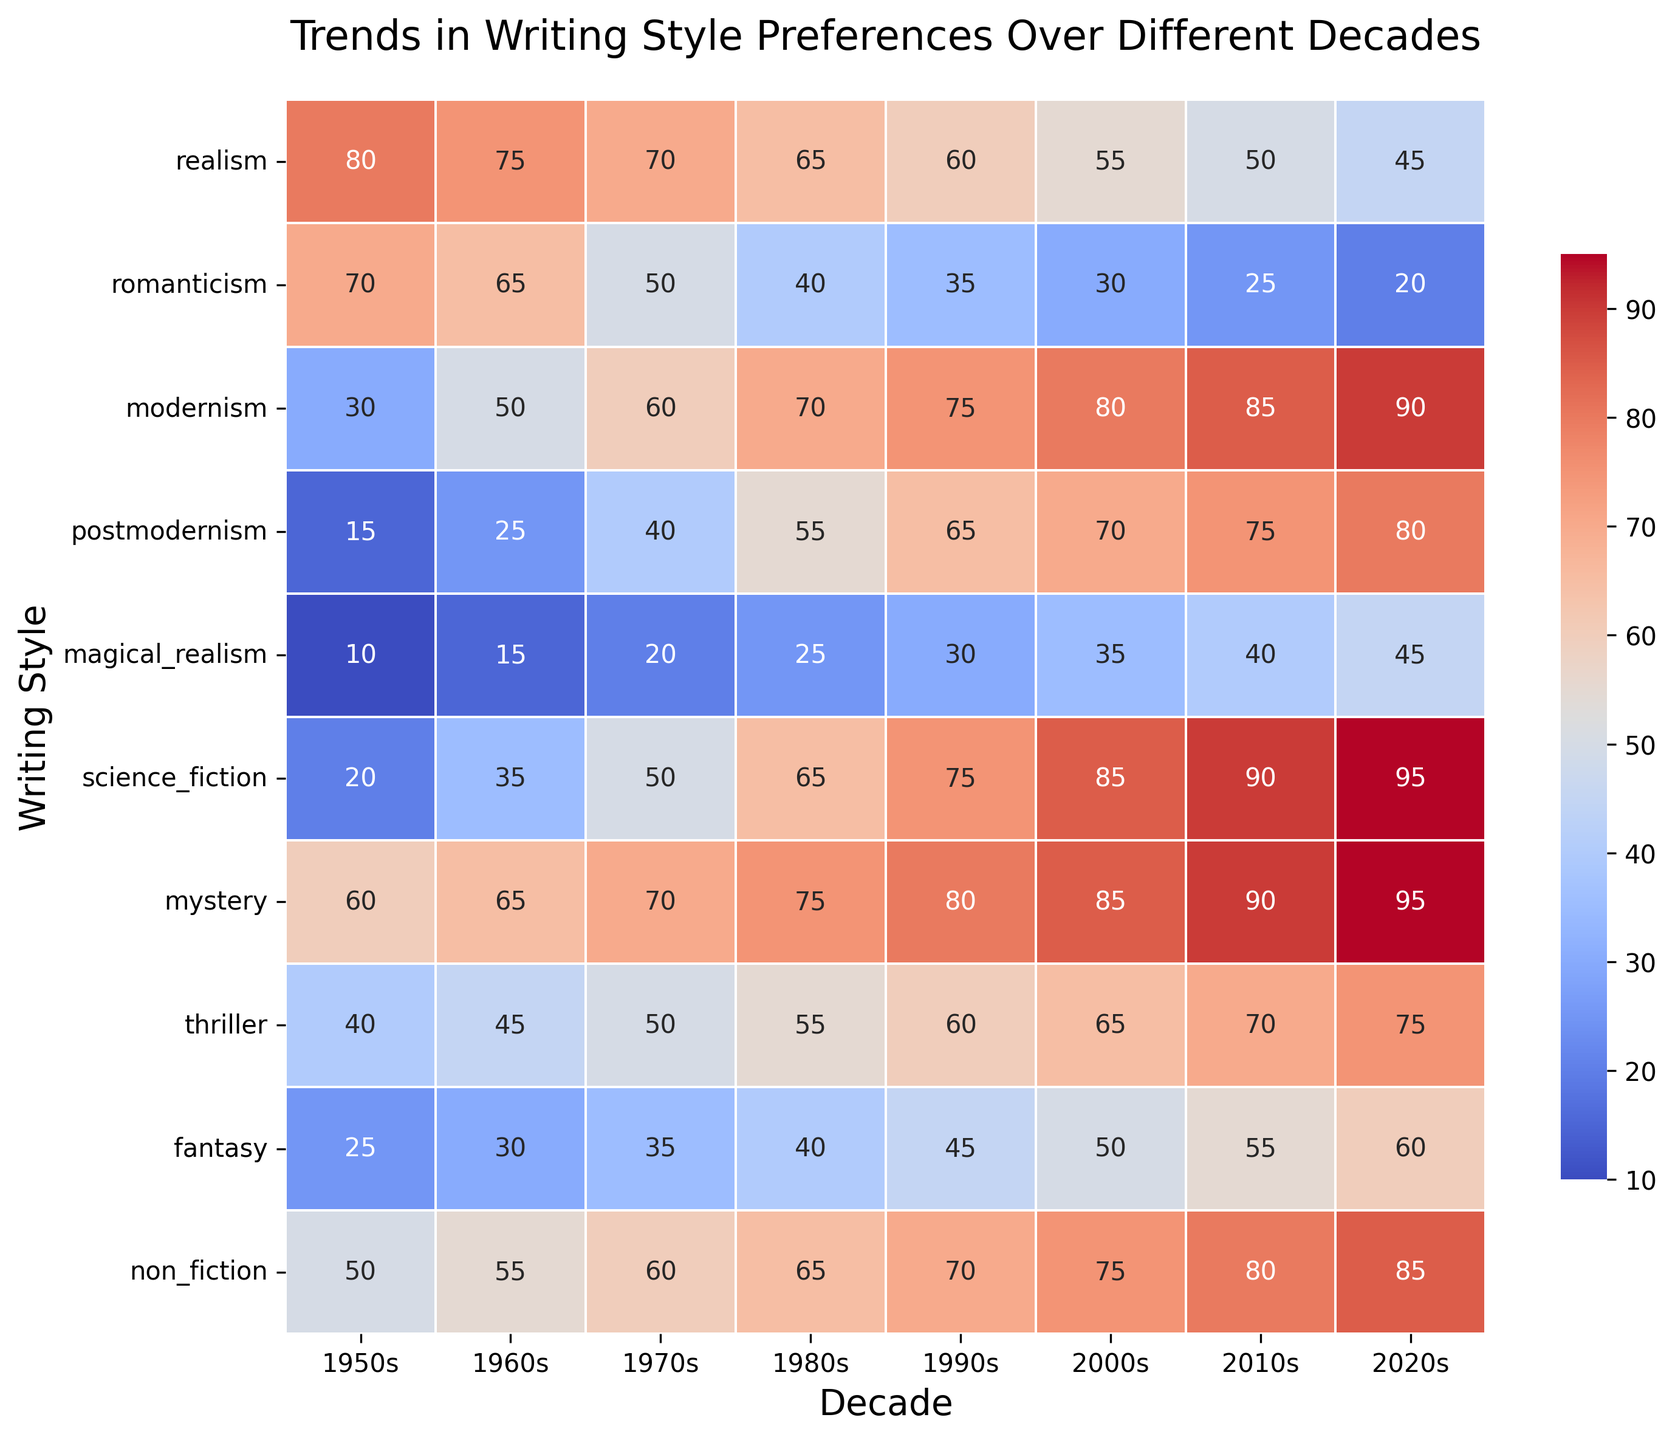Which decade had the highest preference for realism? The heatmap shows the preference for each style by decade. Find the highest value in the "realism" row. The highest value in the realism row is for the 1950s.
Answer: 1950s Which writing style saw the most significant increase from the 1950s to the 2020s? Compare the values for each style in the 1950s and the 2020s. Calculate the difference for each and find the largest one. Science fiction increased from 20 in the 1950s to 95 in the 2020s, a difference of 75.
Answer: science fiction Between the 1960s and the 1980s, which decade showed a higher preference for postmodernism? Look at the values for postmodernism in the 1960s and 1980s. The value of postmodernism in the 1980s (55) is higher than in the 1960s (25).
Answer: 1980s What is the trend for mystery writing from the 1950s to the 2020s? Review the values for mystery across all decades and identify the trend. The preference for mystery increases from 60 in the 1950s to 95 in the 2020s.
Answer: increasing Compare the preference for fantasy and non-fiction in the 2000s. Which was higher? Look at the values for fantasy (50) and non-fiction (75) in the 2000s. The value for non-fiction is higher.
Answer: non-fiction What was the lowest preference for thriller writing, and in which decade did it occur? Identify the lowest value in the thriller row and determine the corresponding decade. The lowest preference for thriller writing is 40 in the 1950s.
Answer: 1950s What is the average preference for modernism in the dataset? Calculate the average of the values in the modernism row: (30 + 50 + 60 + 70 + 75 + 80 + 85 + 90) / 8. The sum is 540, and dividing by 8 gives an average of 67.5.
Answer: 67.5 Which writing style had the least variation in preference over the decades? Check the range (difference between highest and lowest value) for each style. Non-fiction has the least variation, ranging from 50 to 85, a difference of 35.
Answer: non-fiction 